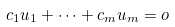Convert formula to latex. <formula><loc_0><loc_0><loc_500><loc_500>c _ { 1 } u _ { 1 } + \cdots + c _ { m } u _ { m } = o</formula> 